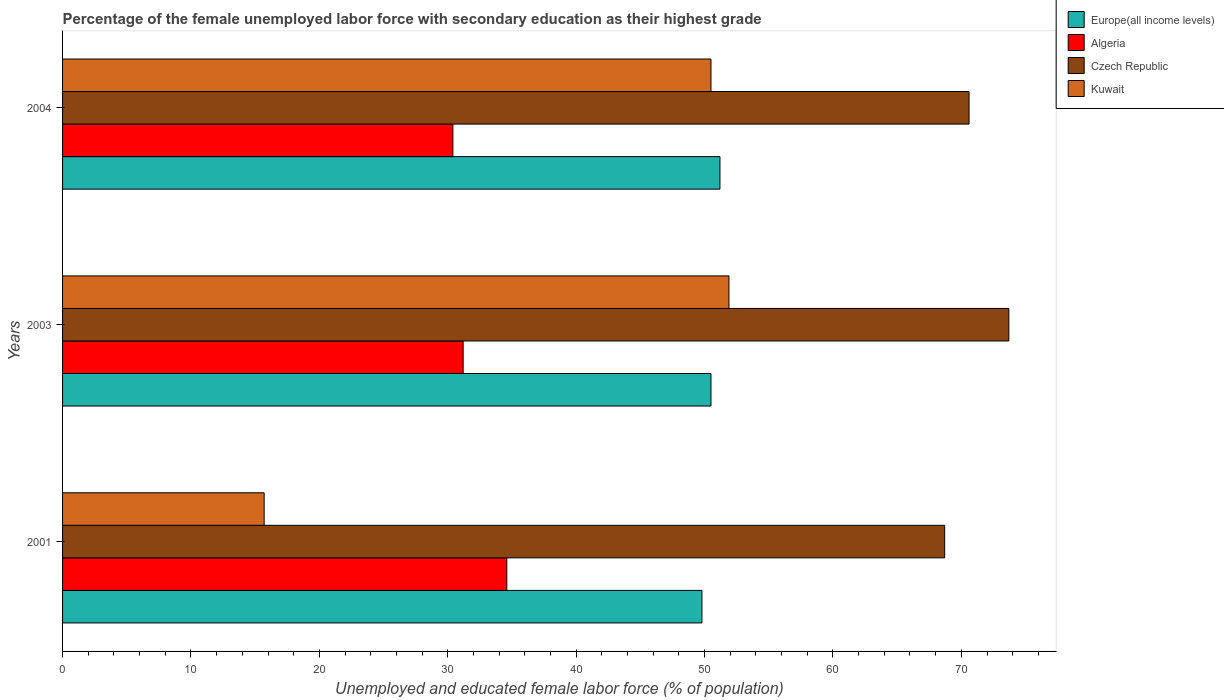How many different coloured bars are there?
Your response must be concise. 4. How many groups of bars are there?
Your answer should be very brief. 3. Are the number of bars on each tick of the Y-axis equal?
Your response must be concise. Yes. In how many cases, is the number of bars for a given year not equal to the number of legend labels?
Offer a terse response. 0. What is the percentage of the unemployed female labor force with secondary education in Czech Republic in 2004?
Give a very brief answer. 70.6. Across all years, what is the maximum percentage of the unemployed female labor force with secondary education in Czech Republic?
Provide a succinct answer. 73.7. Across all years, what is the minimum percentage of the unemployed female labor force with secondary education in Kuwait?
Give a very brief answer. 15.7. What is the total percentage of the unemployed female labor force with secondary education in Europe(all income levels) in the graph?
Give a very brief answer. 151.5. What is the difference between the percentage of the unemployed female labor force with secondary education in Europe(all income levels) in 2001 and that in 2003?
Provide a short and direct response. -0.7. What is the difference between the percentage of the unemployed female labor force with secondary education in Kuwait in 2001 and the percentage of the unemployed female labor force with secondary education in Algeria in 2003?
Ensure brevity in your answer.  -15.5. What is the average percentage of the unemployed female labor force with secondary education in Czech Republic per year?
Your response must be concise. 71. In the year 2004, what is the difference between the percentage of the unemployed female labor force with secondary education in Kuwait and percentage of the unemployed female labor force with secondary education in Europe(all income levels)?
Offer a very short reply. -0.7. What is the ratio of the percentage of the unemployed female labor force with secondary education in Algeria in 2003 to that in 2004?
Give a very brief answer. 1.03. Is the percentage of the unemployed female labor force with secondary education in Europe(all income levels) in 2001 less than that in 2004?
Ensure brevity in your answer.  Yes. What is the difference between the highest and the second highest percentage of the unemployed female labor force with secondary education in Czech Republic?
Keep it short and to the point. 3.1. What is the difference between the highest and the lowest percentage of the unemployed female labor force with secondary education in Czech Republic?
Your response must be concise. 5. In how many years, is the percentage of the unemployed female labor force with secondary education in Europe(all income levels) greater than the average percentage of the unemployed female labor force with secondary education in Europe(all income levels) taken over all years?
Provide a succinct answer. 2. What does the 3rd bar from the top in 2001 represents?
Offer a terse response. Algeria. What does the 3rd bar from the bottom in 2004 represents?
Provide a succinct answer. Czech Republic. Is it the case that in every year, the sum of the percentage of the unemployed female labor force with secondary education in Kuwait and percentage of the unemployed female labor force with secondary education in Europe(all income levels) is greater than the percentage of the unemployed female labor force with secondary education in Czech Republic?
Offer a very short reply. No. Are all the bars in the graph horizontal?
Provide a short and direct response. Yes. How many years are there in the graph?
Offer a very short reply. 3. Where does the legend appear in the graph?
Make the answer very short. Top right. How many legend labels are there?
Your response must be concise. 4. What is the title of the graph?
Your answer should be compact. Percentage of the female unemployed labor force with secondary education as their highest grade. What is the label or title of the X-axis?
Keep it short and to the point. Unemployed and educated female labor force (% of population). What is the label or title of the Y-axis?
Ensure brevity in your answer.  Years. What is the Unemployed and educated female labor force (% of population) of Europe(all income levels) in 2001?
Offer a terse response. 49.8. What is the Unemployed and educated female labor force (% of population) in Algeria in 2001?
Your answer should be very brief. 34.6. What is the Unemployed and educated female labor force (% of population) of Czech Republic in 2001?
Your response must be concise. 68.7. What is the Unemployed and educated female labor force (% of population) of Kuwait in 2001?
Provide a succinct answer. 15.7. What is the Unemployed and educated female labor force (% of population) in Europe(all income levels) in 2003?
Offer a very short reply. 50.5. What is the Unemployed and educated female labor force (% of population) in Algeria in 2003?
Your answer should be compact. 31.2. What is the Unemployed and educated female labor force (% of population) in Czech Republic in 2003?
Your response must be concise. 73.7. What is the Unemployed and educated female labor force (% of population) in Kuwait in 2003?
Provide a short and direct response. 51.9. What is the Unemployed and educated female labor force (% of population) of Europe(all income levels) in 2004?
Keep it short and to the point. 51.2. What is the Unemployed and educated female labor force (% of population) in Algeria in 2004?
Ensure brevity in your answer.  30.4. What is the Unemployed and educated female labor force (% of population) of Czech Republic in 2004?
Your answer should be compact. 70.6. What is the Unemployed and educated female labor force (% of population) in Kuwait in 2004?
Make the answer very short. 50.5. Across all years, what is the maximum Unemployed and educated female labor force (% of population) of Europe(all income levels)?
Offer a terse response. 51.2. Across all years, what is the maximum Unemployed and educated female labor force (% of population) of Algeria?
Give a very brief answer. 34.6. Across all years, what is the maximum Unemployed and educated female labor force (% of population) of Czech Republic?
Provide a short and direct response. 73.7. Across all years, what is the maximum Unemployed and educated female labor force (% of population) in Kuwait?
Provide a short and direct response. 51.9. Across all years, what is the minimum Unemployed and educated female labor force (% of population) of Europe(all income levels)?
Your answer should be compact. 49.8. Across all years, what is the minimum Unemployed and educated female labor force (% of population) of Algeria?
Provide a short and direct response. 30.4. Across all years, what is the minimum Unemployed and educated female labor force (% of population) of Czech Republic?
Give a very brief answer. 68.7. Across all years, what is the minimum Unemployed and educated female labor force (% of population) in Kuwait?
Offer a terse response. 15.7. What is the total Unemployed and educated female labor force (% of population) in Europe(all income levels) in the graph?
Your response must be concise. 151.5. What is the total Unemployed and educated female labor force (% of population) of Algeria in the graph?
Provide a short and direct response. 96.2. What is the total Unemployed and educated female labor force (% of population) in Czech Republic in the graph?
Offer a very short reply. 213. What is the total Unemployed and educated female labor force (% of population) of Kuwait in the graph?
Offer a terse response. 118.1. What is the difference between the Unemployed and educated female labor force (% of population) in Europe(all income levels) in 2001 and that in 2003?
Offer a terse response. -0.7. What is the difference between the Unemployed and educated female labor force (% of population) in Algeria in 2001 and that in 2003?
Keep it short and to the point. 3.4. What is the difference between the Unemployed and educated female labor force (% of population) of Kuwait in 2001 and that in 2003?
Offer a terse response. -36.2. What is the difference between the Unemployed and educated female labor force (% of population) in Europe(all income levels) in 2001 and that in 2004?
Ensure brevity in your answer.  -1.4. What is the difference between the Unemployed and educated female labor force (% of population) of Czech Republic in 2001 and that in 2004?
Your answer should be compact. -1.9. What is the difference between the Unemployed and educated female labor force (% of population) of Kuwait in 2001 and that in 2004?
Provide a short and direct response. -34.8. What is the difference between the Unemployed and educated female labor force (% of population) of Czech Republic in 2003 and that in 2004?
Offer a terse response. 3.1. What is the difference between the Unemployed and educated female labor force (% of population) in Europe(all income levels) in 2001 and the Unemployed and educated female labor force (% of population) in Algeria in 2003?
Offer a very short reply. 18.6. What is the difference between the Unemployed and educated female labor force (% of population) of Europe(all income levels) in 2001 and the Unemployed and educated female labor force (% of population) of Czech Republic in 2003?
Offer a terse response. -23.9. What is the difference between the Unemployed and educated female labor force (% of population) of Europe(all income levels) in 2001 and the Unemployed and educated female labor force (% of population) of Kuwait in 2003?
Your answer should be very brief. -2.1. What is the difference between the Unemployed and educated female labor force (% of population) in Algeria in 2001 and the Unemployed and educated female labor force (% of population) in Czech Republic in 2003?
Offer a very short reply. -39.1. What is the difference between the Unemployed and educated female labor force (% of population) in Algeria in 2001 and the Unemployed and educated female labor force (% of population) in Kuwait in 2003?
Give a very brief answer. -17.3. What is the difference between the Unemployed and educated female labor force (% of population) of Czech Republic in 2001 and the Unemployed and educated female labor force (% of population) of Kuwait in 2003?
Provide a succinct answer. 16.8. What is the difference between the Unemployed and educated female labor force (% of population) of Europe(all income levels) in 2001 and the Unemployed and educated female labor force (% of population) of Algeria in 2004?
Your answer should be compact. 19.4. What is the difference between the Unemployed and educated female labor force (% of population) in Europe(all income levels) in 2001 and the Unemployed and educated female labor force (% of population) in Czech Republic in 2004?
Offer a very short reply. -20.8. What is the difference between the Unemployed and educated female labor force (% of population) of Europe(all income levels) in 2001 and the Unemployed and educated female labor force (% of population) of Kuwait in 2004?
Make the answer very short. -0.7. What is the difference between the Unemployed and educated female labor force (% of population) of Algeria in 2001 and the Unemployed and educated female labor force (% of population) of Czech Republic in 2004?
Your response must be concise. -36. What is the difference between the Unemployed and educated female labor force (% of population) in Algeria in 2001 and the Unemployed and educated female labor force (% of population) in Kuwait in 2004?
Offer a terse response. -15.9. What is the difference between the Unemployed and educated female labor force (% of population) of Europe(all income levels) in 2003 and the Unemployed and educated female labor force (% of population) of Algeria in 2004?
Offer a terse response. 20.1. What is the difference between the Unemployed and educated female labor force (% of population) in Europe(all income levels) in 2003 and the Unemployed and educated female labor force (% of population) in Czech Republic in 2004?
Ensure brevity in your answer.  -20.1. What is the difference between the Unemployed and educated female labor force (% of population) in Europe(all income levels) in 2003 and the Unemployed and educated female labor force (% of population) in Kuwait in 2004?
Give a very brief answer. -0. What is the difference between the Unemployed and educated female labor force (% of population) of Algeria in 2003 and the Unemployed and educated female labor force (% of population) of Czech Republic in 2004?
Keep it short and to the point. -39.4. What is the difference between the Unemployed and educated female labor force (% of population) of Algeria in 2003 and the Unemployed and educated female labor force (% of population) of Kuwait in 2004?
Provide a succinct answer. -19.3. What is the difference between the Unemployed and educated female labor force (% of population) in Czech Republic in 2003 and the Unemployed and educated female labor force (% of population) in Kuwait in 2004?
Offer a very short reply. 23.2. What is the average Unemployed and educated female labor force (% of population) in Europe(all income levels) per year?
Offer a very short reply. 50.5. What is the average Unemployed and educated female labor force (% of population) in Algeria per year?
Make the answer very short. 32.07. What is the average Unemployed and educated female labor force (% of population) of Kuwait per year?
Provide a succinct answer. 39.37. In the year 2001, what is the difference between the Unemployed and educated female labor force (% of population) in Europe(all income levels) and Unemployed and educated female labor force (% of population) in Algeria?
Offer a very short reply. 15.2. In the year 2001, what is the difference between the Unemployed and educated female labor force (% of population) in Europe(all income levels) and Unemployed and educated female labor force (% of population) in Czech Republic?
Your answer should be compact. -18.9. In the year 2001, what is the difference between the Unemployed and educated female labor force (% of population) of Europe(all income levels) and Unemployed and educated female labor force (% of population) of Kuwait?
Provide a short and direct response. 34.1. In the year 2001, what is the difference between the Unemployed and educated female labor force (% of population) in Algeria and Unemployed and educated female labor force (% of population) in Czech Republic?
Give a very brief answer. -34.1. In the year 2001, what is the difference between the Unemployed and educated female labor force (% of population) of Czech Republic and Unemployed and educated female labor force (% of population) of Kuwait?
Ensure brevity in your answer.  53. In the year 2003, what is the difference between the Unemployed and educated female labor force (% of population) in Europe(all income levels) and Unemployed and educated female labor force (% of population) in Algeria?
Your response must be concise. 19.3. In the year 2003, what is the difference between the Unemployed and educated female labor force (% of population) in Europe(all income levels) and Unemployed and educated female labor force (% of population) in Czech Republic?
Make the answer very short. -23.2. In the year 2003, what is the difference between the Unemployed and educated female labor force (% of population) in Europe(all income levels) and Unemployed and educated female labor force (% of population) in Kuwait?
Make the answer very short. -1.4. In the year 2003, what is the difference between the Unemployed and educated female labor force (% of population) of Algeria and Unemployed and educated female labor force (% of population) of Czech Republic?
Provide a short and direct response. -42.5. In the year 2003, what is the difference between the Unemployed and educated female labor force (% of population) of Algeria and Unemployed and educated female labor force (% of population) of Kuwait?
Provide a succinct answer. -20.7. In the year 2003, what is the difference between the Unemployed and educated female labor force (% of population) in Czech Republic and Unemployed and educated female labor force (% of population) in Kuwait?
Make the answer very short. 21.8. In the year 2004, what is the difference between the Unemployed and educated female labor force (% of population) of Europe(all income levels) and Unemployed and educated female labor force (% of population) of Algeria?
Provide a succinct answer. 20.8. In the year 2004, what is the difference between the Unemployed and educated female labor force (% of population) in Europe(all income levels) and Unemployed and educated female labor force (% of population) in Czech Republic?
Give a very brief answer. -19.4. In the year 2004, what is the difference between the Unemployed and educated female labor force (% of population) in Europe(all income levels) and Unemployed and educated female labor force (% of population) in Kuwait?
Provide a short and direct response. 0.7. In the year 2004, what is the difference between the Unemployed and educated female labor force (% of population) of Algeria and Unemployed and educated female labor force (% of population) of Czech Republic?
Your answer should be very brief. -40.2. In the year 2004, what is the difference between the Unemployed and educated female labor force (% of population) in Algeria and Unemployed and educated female labor force (% of population) in Kuwait?
Make the answer very short. -20.1. In the year 2004, what is the difference between the Unemployed and educated female labor force (% of population) in Czech Republic and Unemployed and educated female labor force (% of population) in Kuwait?
Your answer should be very brief. 20.1. What is the ratio of the Unemployed and educated female labor force (% of population) of Europe(all income levels) in 2001 to that in 2003?
Provide a succinct answer. 0.99. What is the ratio of the Unemployed and educated female labor force (% of population) of Algeria in 2001 to that in 2003?
Keep it short and to the point. 1.11. What is the ratio of the Unemployed and educated female labor force (% of population) of Czech Republic in 2001 to that in 2003?
Provide a succinct answer. 0.93. What is the ratio of the Unemployed and educated female labor force (% of population) in Kuwait in 2001 to that in 2003?
Keep it short and to the point. 0.3. What is the ratio of the Unemployed and educated female labor force (% of population) in Europe(all income levels) in 2001 to that in 2004?
Offer a very short reply. 0.97. What is the ratio of the Unemployed and educated female labor force (% of population) of Algeria in 2001 to that in 2004?
Your answer should be very brief. 1.14. What is the ratio of the Unemployed and educated female labor force (% of population) of Czech Republic in 2001 to that in 2004?
Offer a terse response. 0.97. What is the ratio of the Unemployed and educated female labor force (% of population) in Kuwait in 2001 to that in 2004?
Make the answer very short. 0.31. What is the ratio of the Unemployed and educated female labor force (% of population) in Europe(all income levels) in 2003 to that in 2004?
Your answer should be very brief. 0.99. What is the ratio of the Unemployed and educated female labor force (% of population) of Algeria in 2003 to that in 2004?
Give a very brief answer. 1.03. What is the ratio of the Unemployed and educated female labor force (% of population) in Czech Republic in 2003 to that in 2004?
Provide a short and direct response. 1.04. What is the ratio of the Unemployed and educated female labor force (% of population) in Kuwait in 2003 to that in 2004?
Give a very brief answer. 1.03. What is the difference between the highest and the second highest Unemployed and educated female labor force (% of population) of Czech Republic?
Your response must be concise. 3.1. What is the difference between the highest and the lowest Unemployed and educated female labor force (% of population) in Europe(all income levels)?
Keep it short and to the point. 1.4. What is the difference between the highest and the lowest Unemployed and educated female labor force (% of population) of Kuwait?
Ensure brevity in your answer.  36.2. 